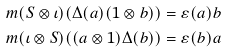<formula> <loc_0><loc_0><loc_500><loc_500>& m ( S \otimes \iota ) ( \Delta ( a ) ( 1 \otimes b ) ) = \varepsilon ( a ) b \\ & m ( \iota \otimes S ) ( ( a \otimes 1 ) \Delta ( b ) ) = \varepsilon ( b ) a</formula> 